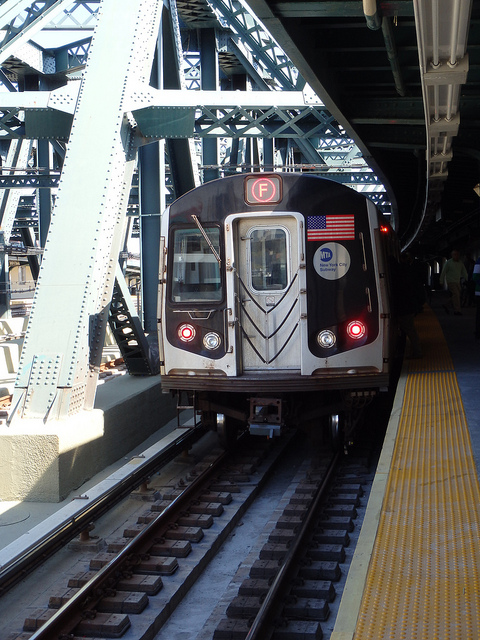Please identify all text content in this image. F 